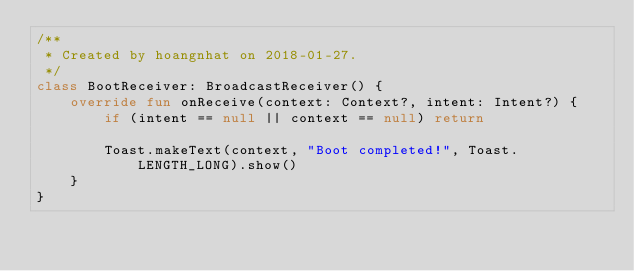Convert code to text. <code><loc_0><loc_0><loc_500><loc_500><_Kotlin_>/**
 * Created by hoangnhat on 2018-01-27.
 */
class BootReceiver: BroadcastReceiver() {
    override fun onReceive(context: Context?, intent: Intent?) {
        if (intent == null || context == null) return

        Toast.makeText(context, "Boot completed!", Toast.LENGTH_LONG).show()
    }
}
</code> 